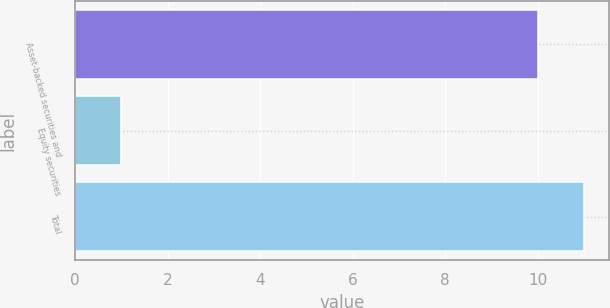Convert chart to OTSL. <chart><loc_0><loc_0><loc_500><loc_500><bar_chart><fcel>Asset-backed securities and<fcel>Equity securities<fcel>Total<nl><fcel>10<fcel>1<fcel>11<nl></chart> 